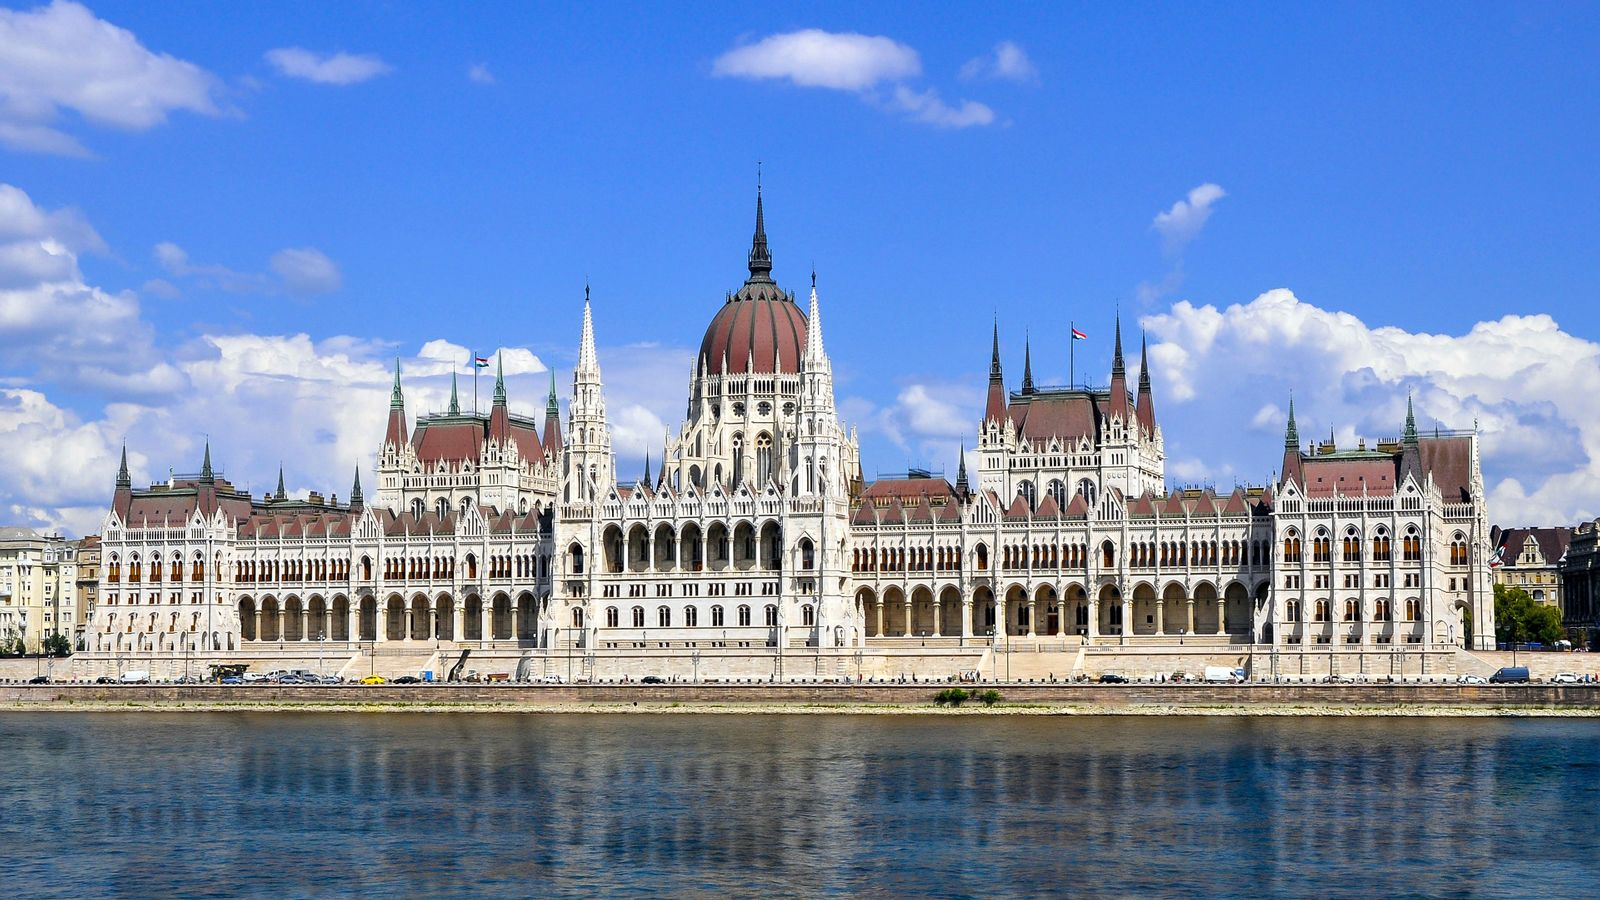A realistic scenario (long). As you stroll along the Danube Promenade on a crisp spring morning, you are greeted by the sight of the Hungarian Parliament Building, bathed in the soft glow of the rising sun. The air is filled with the scent of blooming flowers from nearby gardens, and the occasional sound of a tram bell echoes through the streets. You pause to take in the intricate details of the building, marveling at the craftsmanship that went into every arch and spire. Boats gently glide along the river, creating ripples that reflect the majestic structure. You decide to join a guided tour, stepping inside to explore the opulent interiors—grand staircases, lavish chambers, and the impressive central hall. The guide's narration brings to life stories of Hungary's past, enriching your experience. After the tour, a leisurely lunch at a nearby café allows you to savor traditional Hungarian cuisine while continuing to admire the view of this architectural gem. The day ends with a river cruise, offering a different perspective of the Parliament Building illuminated against the twilight sky, leaving you with memories of a day steeped in history and beauty. 